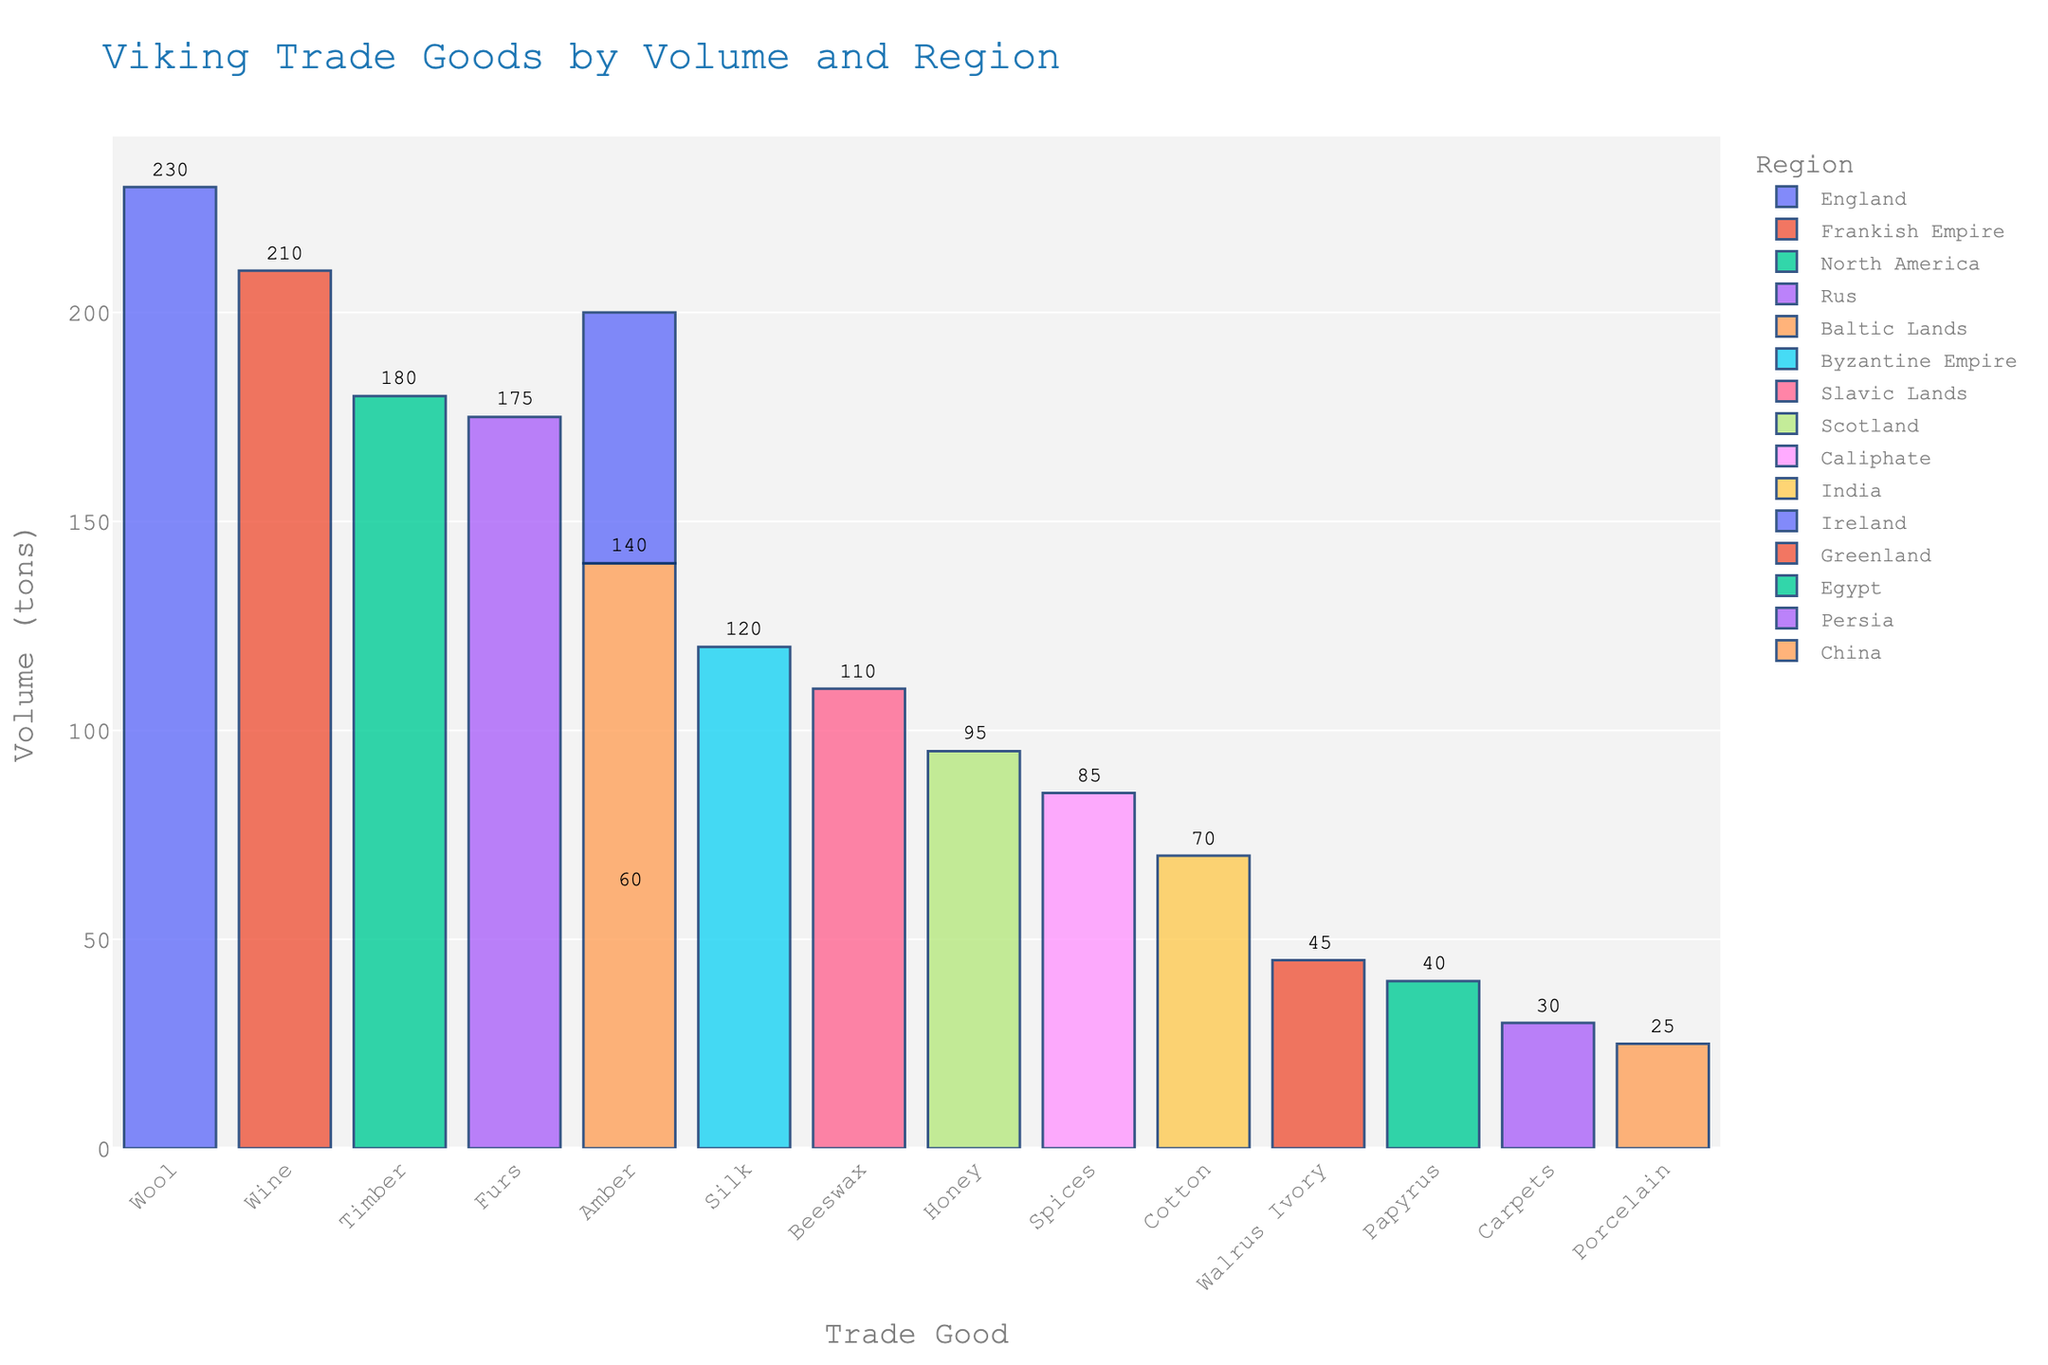What trade good has the highest volume imported by the Vikings? The tallest bar on the chart represents 'Wool' from 'England' with a volume of 230 tons, indicating it has the highest volume.
Answer: Wool Which regions supplied amber to Vikings, and what were their respective volumes? The bars labeled 'Amber' show that 'Ireland' supplied 60 tons and 'Baltic Lands' supplied 140 tons.
Answer: Ireland: 60 tons, Baltic Lands: 140 tons What's the total volume of goods imported from the Byzantine Empire and the Frankish Empire combined? Adding the volumes from the Byzantine Empire (Silk: 120 tons) and Frankish Empire (Wine: 210 tons), the total is 120 + 210 = 330 tons.
Answer: 330 tons What is the difference in volume between the trade goods from the Frankish Empire and the Caliphate? The Frankish Empire imported 210 tons of Wine, and the Caliphate imported 85 tons of Spices, resulting in a difference of 210 - 85 = 125 tons.
Answer: 125 tons Which imported trade good has the least volume, and what region is it from? The shortest bar on the chart represents 'Porcelain' from 'China' with a volume of 25 tons.
Answer: Porcelain from China How many trade goods have volumes greater than 100 tons? Counting the bars with volumes over 100 tons includes 'Wool', 'Wine', 'Timber', 'Furs', 'Amber' (from Baltic Lands), 'Silk', and 'Beeswax', which totals 7 goods.
Answer: 7 goods Which trade good has a higher volume: Honey from Scotland or Beeswax from Slavic Lands? Comparing the bars, 'Honey' from 'Scotland' (95 tons) is less than 'Beeswax' from 'Slavic Lands' (110 tons).
Answer: Beeswax from Slavic Lands What is the combined volume of all trade goods from Scandinavia's immediate neighbors (England, Ireland, Scotland)? Summing the volumes from England (Wool: 230 tons), Ireland (Amber: 60 tons), and Scotland (Honey: 95 tons), the total is 230 + 60 + 95 = 385 tons.
Answer: 385 tons 